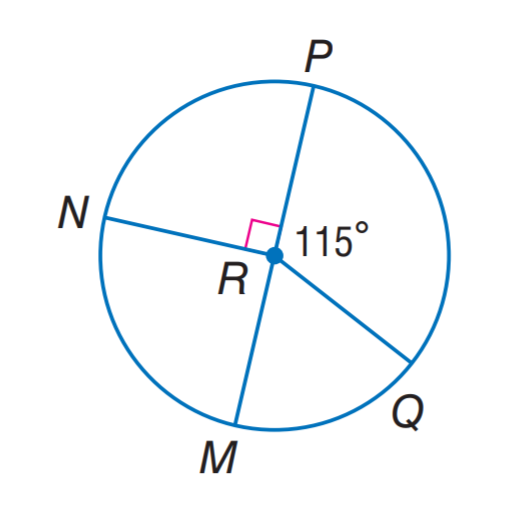Question: P M is a diameter of \odot R. Find m \widehat M N P.
Choices:
A. 120
B. 140
C. 160
D. 180
Answer with the letter. Answer: D Question: P M is a diameter of \odot R. Find m \widehat M Q.
Choices:
A. 45
B. 55
C. 65
D. 75
Answer with the letter. Answer: C Question: P M is a diameter of \odot R. Find m \widehat M N Q.
Choices:
A. 115
B. 225
C. 265
D. 295
Answer with the letter. Answer: D 